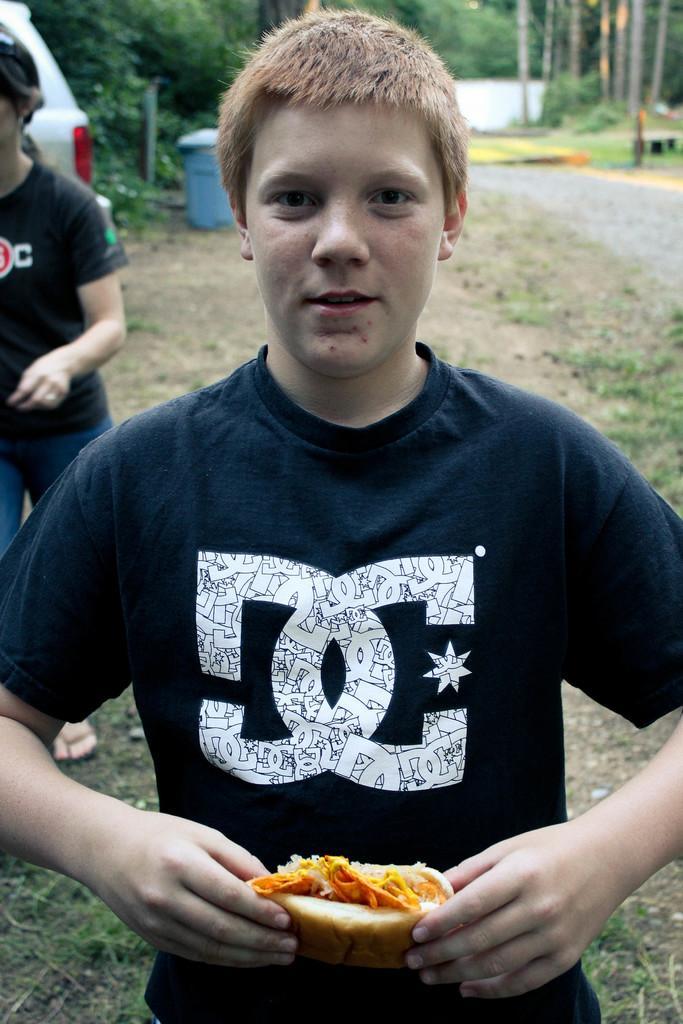Describe this image in one or two sentences. This image consists of a boy wearing black t-shirt and holding a sandwich. At the bottom, there is ground, along with green grass. In the background, there is a car along with dust bin and trees. 